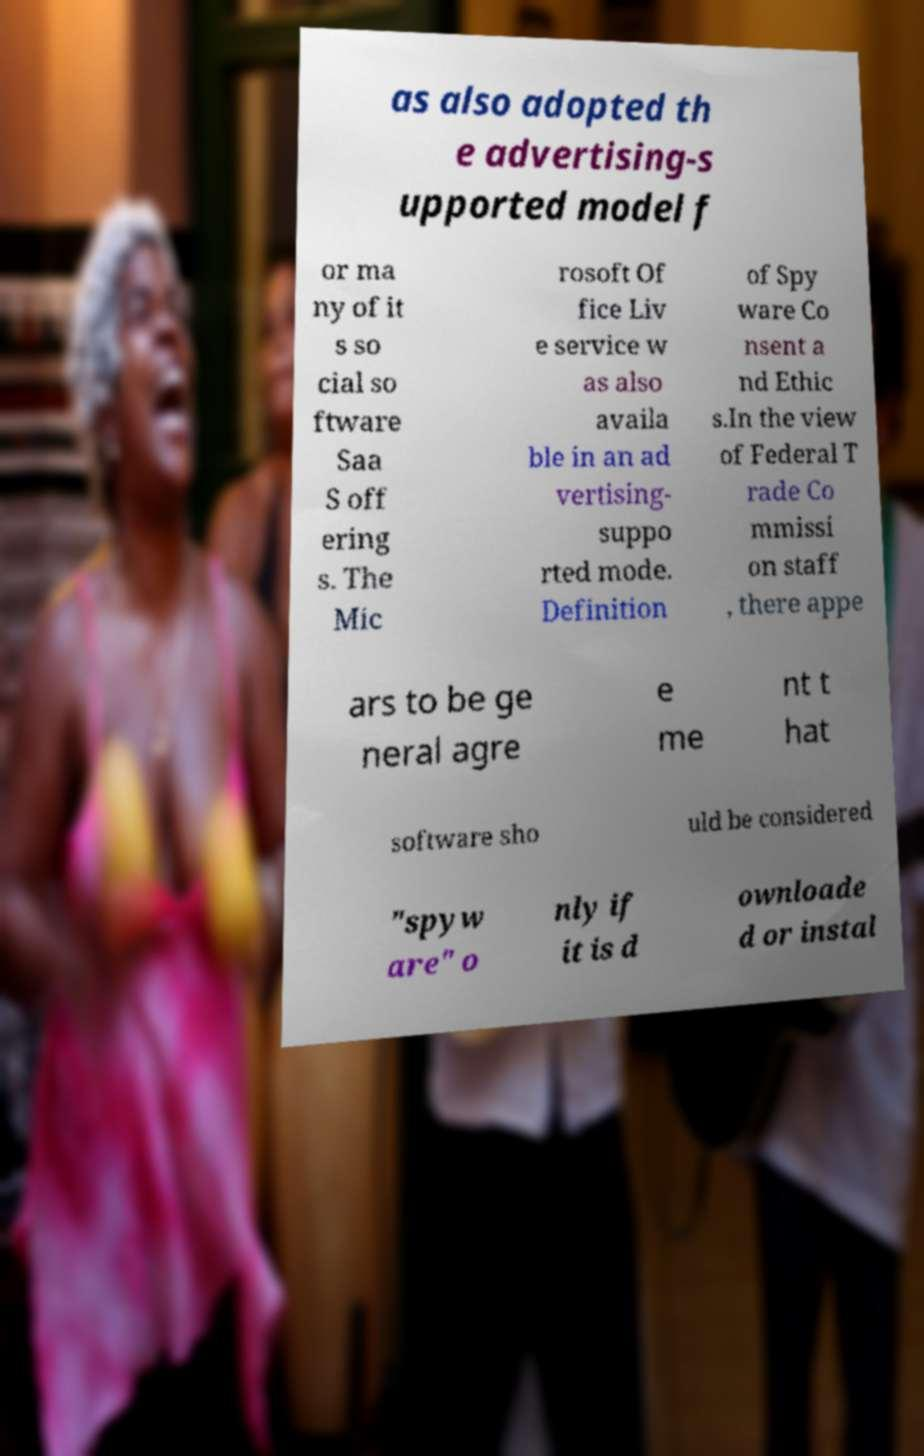Could you assist in decoding the text presented in this image and type it out clearly? as also adopted th e advertising-s upported model f or ma ny of it s so cial so ftware Saa S off ering s. The Mic rosoft Of fice Liv e service w as also availa ble in an ad vertising- suppo rted mode. Definition of Spy ware Co nsent a nd Ethic s.In the view of Federal T rade Co mmissi on staff , there appe ars to be ge neral agre e me nt t hat software sho uld be considered "spyw are" o nly if it is d ownloade d or instal 